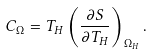<formula> <loc_0><loc_0><loc_500><loc_500>C _ { \Omega } = T _ { H } \left ( \frac { \partial S } { \partial T _ { H } } \right ) _ { \Omega _ { H } } .</formula> 